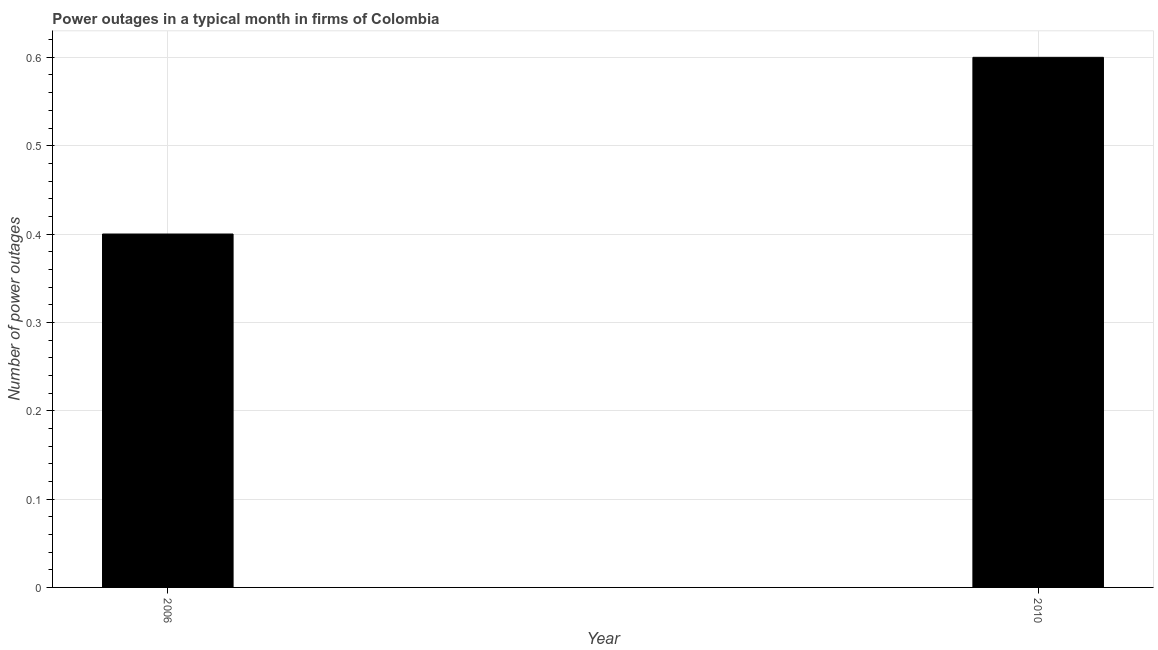Does the graph contain any zero values?
Your response must be concise. No. Does the graph contain grids?
Your answer should be very brief. Yes. What is the title of the graph?
Keep it short and to the point. Power outages in a typical month in firms of Colombia. What is the label or title of the Y-axis?
Give a very brief answer. Number of power outages. Across all years, what is the maximum number of power outages?
Offer a terse response. 0.6. Across all years, what is the minimum number of power outages?
Give a very brief answer. 0.4. In which year was the number of power outages maximum?
Provide a short and direct response. 2010. What is the sum of the number of power outages?
Make the answer very short. 1. What is the ratio of the number of power outages in 2006 to that in 2010?
Offer a very short reply. 0.67. How many bars are there?
Keep it short and to the point. 2. Are all the bars in the graph horizontal?
Ensure brevity in your answer.  No. What is the Number of power outages in 2010?
Your answer should be very brief. 0.6. What is the ratio of the Number of power outages in 2006 to that in 2010?
Provide a short and direct response. 0.67. 